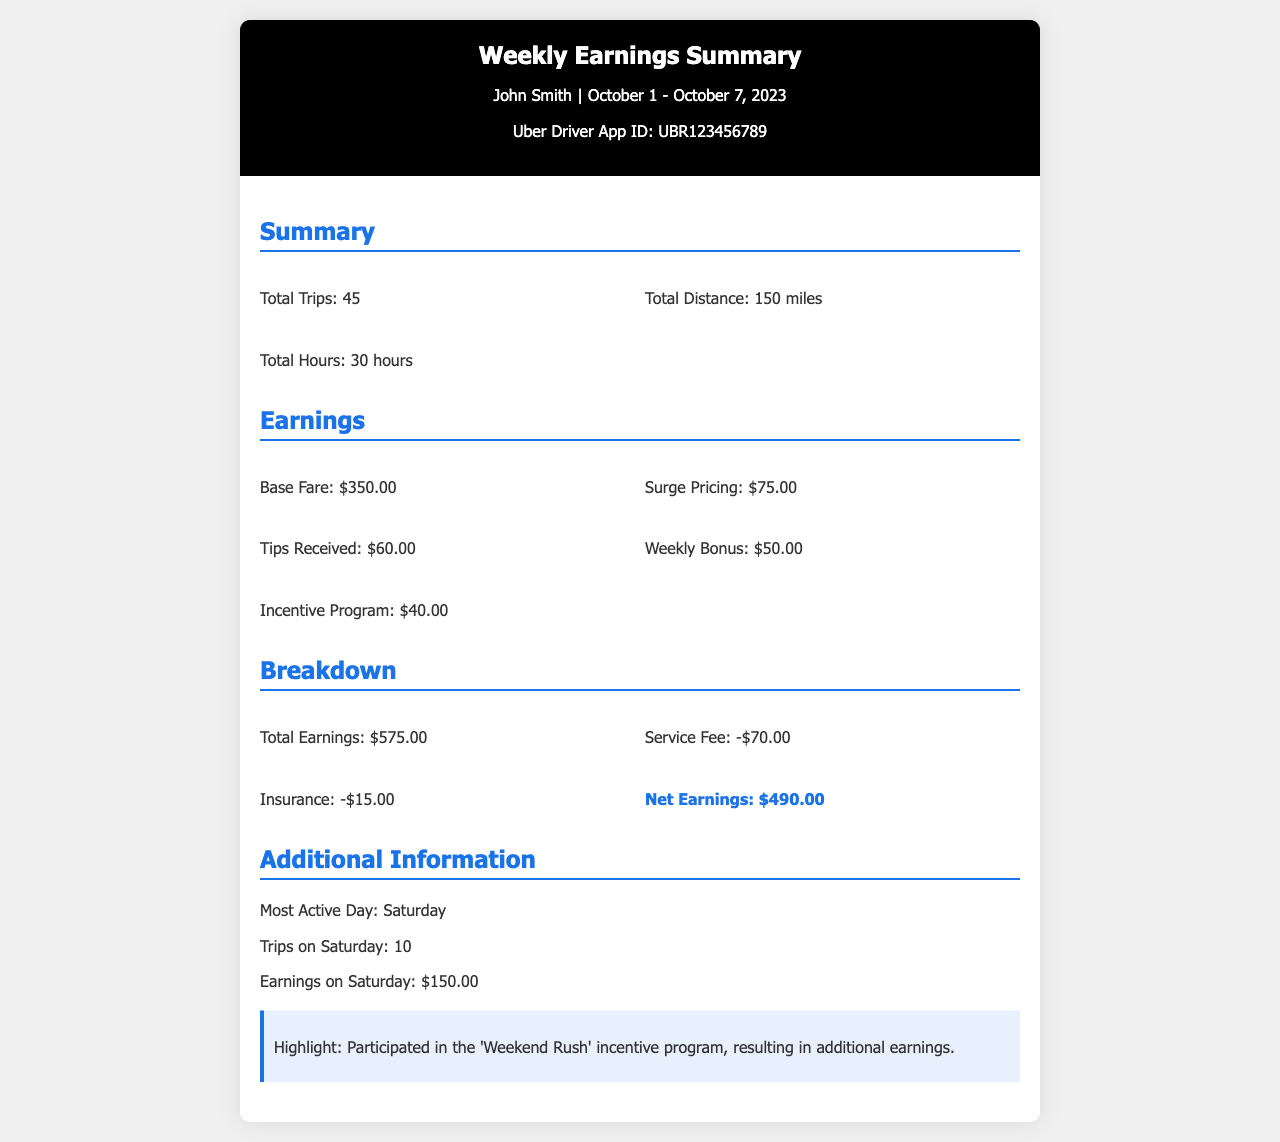What is the total number of trips? The total number of trips is mentioned in the summary section of the document, which states 45 trips.
Answer: 45 What is the total earning from tips? The tips received are listed under the earnings section of the document, amounting to $60.00.
Answer: $60.00 What is the net earnings for the week? The net earnings are calculated by subtracting service fees and insurance from total earnings, which totals $490.00 in the document.
Answer: $490.00 What day did I have the most trips? The document specifies that Saturday was the most active day with the highest number of trips.
Answer: Saturday What was the total distance driven? The total distance driven is stated in the summary and amounts to 150 miles.
Answer: 150 miles How much did I earn from surge pricing? The surge pricing earnings detailed in the earnings section are $75.00.
Answer: $75.00 What was the amount of the weekly bonus? The weekly bonus listed in the earnings section is $50.00.
Answer: $50.00 How many hours did I work? The total hours worked are mentioned in the summary of the document as 30 hours.
Answer: 30 hours What is highlighted about the earnings on Saturday? The highlight mentions participation in the 'Weekend Rush' incentive program leading to additional earnings.
Answer: 'Weekend Rush' incentive program 